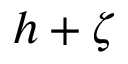<formula> <loc_0><loc_0><loc_500><loc_500>h + \zeta</formula> 